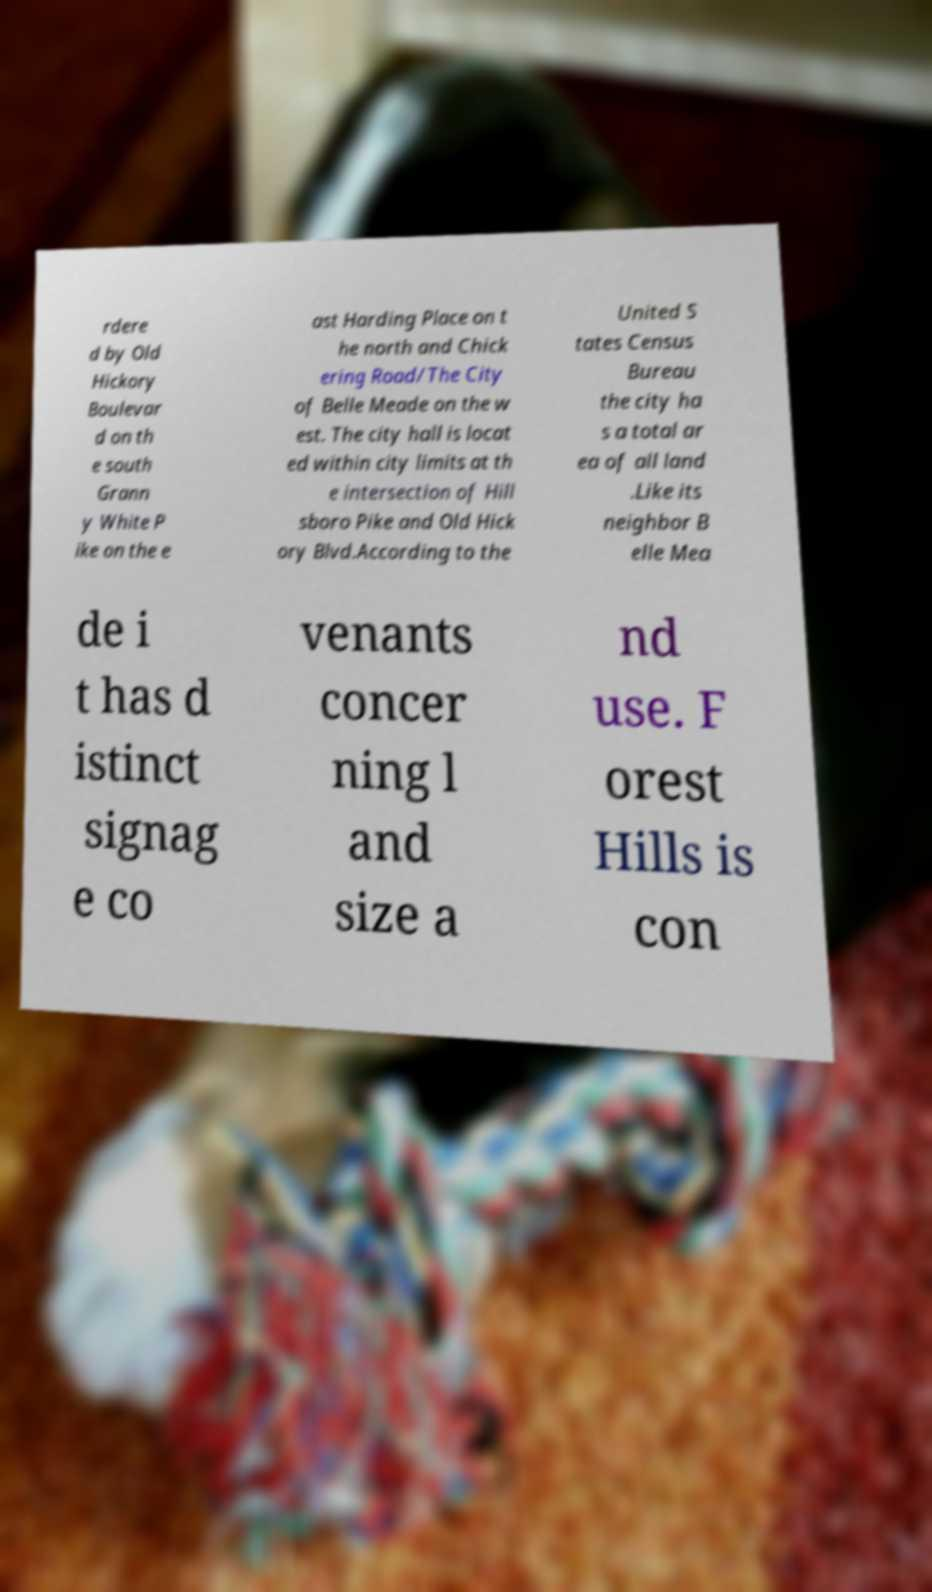Can you read and provide the text displayed in the image?This photo seems to have some interesting text. Can you extract and type it out for me? rdere d by Old Hickory Boulevar d on th e south Grann y White P ike on the e ast Harding Place on t he north and Chick ering Road/The City of Belle Meade on the w est. The city hall is locat ed within city limits at th e intersection of Hill sboro Pike and Old Hick ory Blvd.According to the United S tates Census Bureau the city ha s a total ar ea of all land .Like its neighbor B elle Mea de i t has d istinct signag e co venants concer ning l and size a nd use. F orest Hills is con 